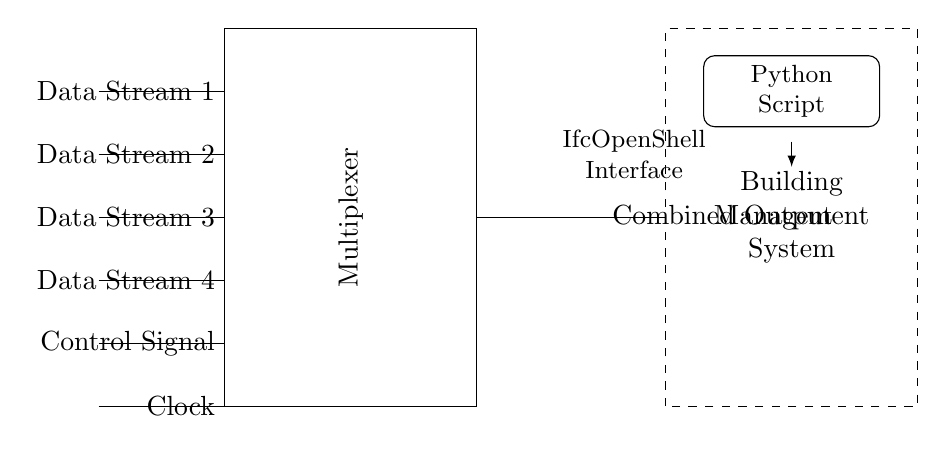What is the purpose of the multiplexer? The multiplexer is used for combining multiple data streams into a single output stream. It selectively transmits one of several input signals based on the control signal provided.
Answer: Combining data streams How many data streams does the multiplexer accept? The circuit diagram shows four input data streams, labeled from one to four. Each stream is connected to the multiplexer for selection.
Answer: Four What is the function of the control signal? The control signal determines which of the four input data streams is selected to be combined at the output. It effectively controls the operation of the multiplexer.
Answer: Selection of input What is the connection between the multiplexer and the building management system? The output of the multiplexer is connected to the building management system, allowing it to receive the combined output of the selected data stream.
Answer: Combined output connection What is the significance of the dashed rectangle? The dashed rectangle represents the building management system, indicating that it is a separate module interfaced with the multiplexer for data management or control.
Answer: Building management system Which interface does the circuit use for communication with the building management system? The circuit uses an IfcOpenShell interface to facilitate communication between the multiplexer and the building management system.
Answer: IfcOpenShell Interface What role does the clock play in this circuit? The clock signal provides timing for the multiplexer, ensuring that the selection of the data streams occurs in synchronization with the data transmission.
Answer: Timing signal 